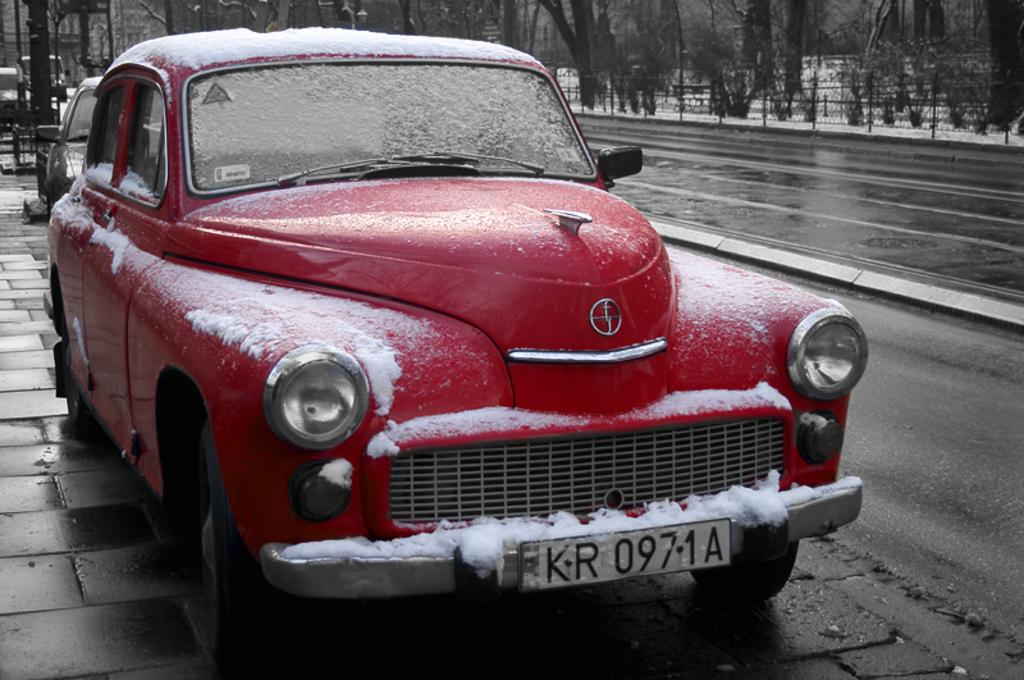What is the main subject in the center of the image? There is a car covered with snow in the center of the image. What can be seen in the background of the image? There are trees and a fence in the background of the image. Are there any other vehicles visible in the image? Yes, other vehicles are visible in the background of the image. What is at the bottom of the image? There is a road at the bottom of the image. How many boats are visible in the image? There are no boats present in the image. What type of disgust can be seen on the car's surface in the image? There is no indication of disgust in the image; it is a car covered with snow. 